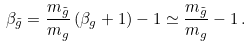Convert formula to latex. <formula><loc_0><loc_0><loc_500><loc_500>\beta _ { \tilde { g } } = \frac { m _ { \tilde { g } } } { m _ { g } } \left ( \beta _ { g } + 1 \right ) - 1 \simeq \frac { m _ { \tilde { g } } } { m _ { g } } - 1 \, .</formula> 